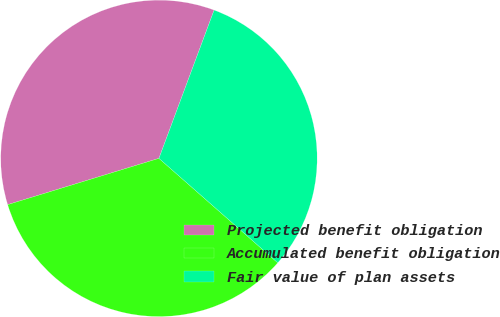<chart> <loc_0><loc_0><loc_500><loc_500><pie_chart><fcel>Projected benefit obligation<fcel>Accumulated benefit obligation<fcel>Fair value of plan assets<nl><fcel>35.4%<fcel>33.8%<fcel>30.81%<nl></chart> 